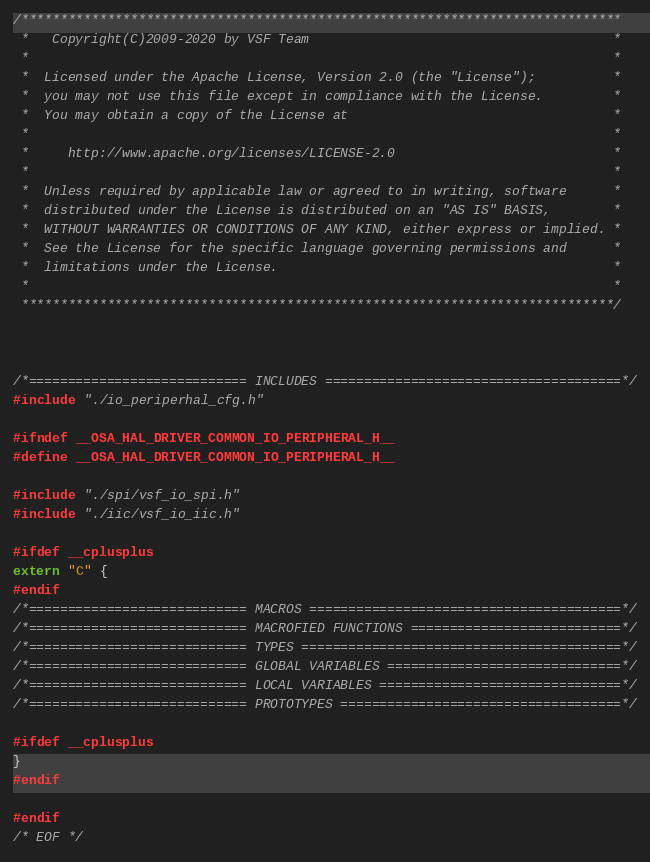<code> <loc_0><loc_0><loc_500><loc_500><_C_>/*****************************************************************************
 *   Copyright(C)2009-2020 by VSF Team                                       *
 *                                                                           *
 *  Licensed under the Apache License, Version 2.0 (the "License");          *
 *  you may not use this file except in compliance with the License.         *
 *  You may obtain a copy of the License at                                  *
 *                                                                           *
 *     http://www.apache.org/licenses/LICENSE-2.0                            *
 *                                                                           *
 *  Unless required by applicable law or agreed to in writing, software      *
 *  distributed under the License is distributed on an "AS IS" BASIS,        *
 *  WITHOUT WARRANTIES OR CONDITIONS OF ANY KIND, either express or implied. *
 *  See the License for the specific language governing permissions and      *
 *  limitations under the License.                                           *
 *                                                                           *
 ****************************************************************************/



/*============================ INCLUDES ======================================*/
#include "./io_periperhal_cfg.h"

#ifndef __OSA_HAL_DRIVER_COMMON_IO_PERIPHERAL_H__
#define __OSA_HAL_DRIVER_COMMON_IO_PERIPHERAL_H__

#include "./spi/vsf_io_spi.h"
#include "./iic/vsf_io_iic.h"

#ifdef __cplusplus
extern "C" {
#endif
/*============================ MACROS ========================================*/
/*============================ MACROFIED FUNCTIONS ===========================*/
/*============================ TYPES =========================================*/
/*============================ GLOBAL VARIABLES ==============================*/
/*============================ LOCAL VARIABLES ===============================*/
/*============================ PROTOTYPES ====================================*/

#ifdef __cplusplus
}
#endif

#endif
/* EOF */
</code> 